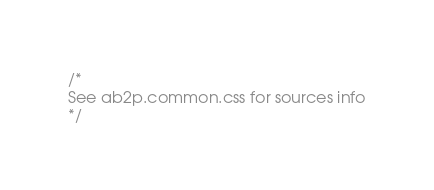<code> <loc_0><loc_0><loc_500><loc_500><_CSS_>/*
See ab2p.common.css for sources info
*/</code> 